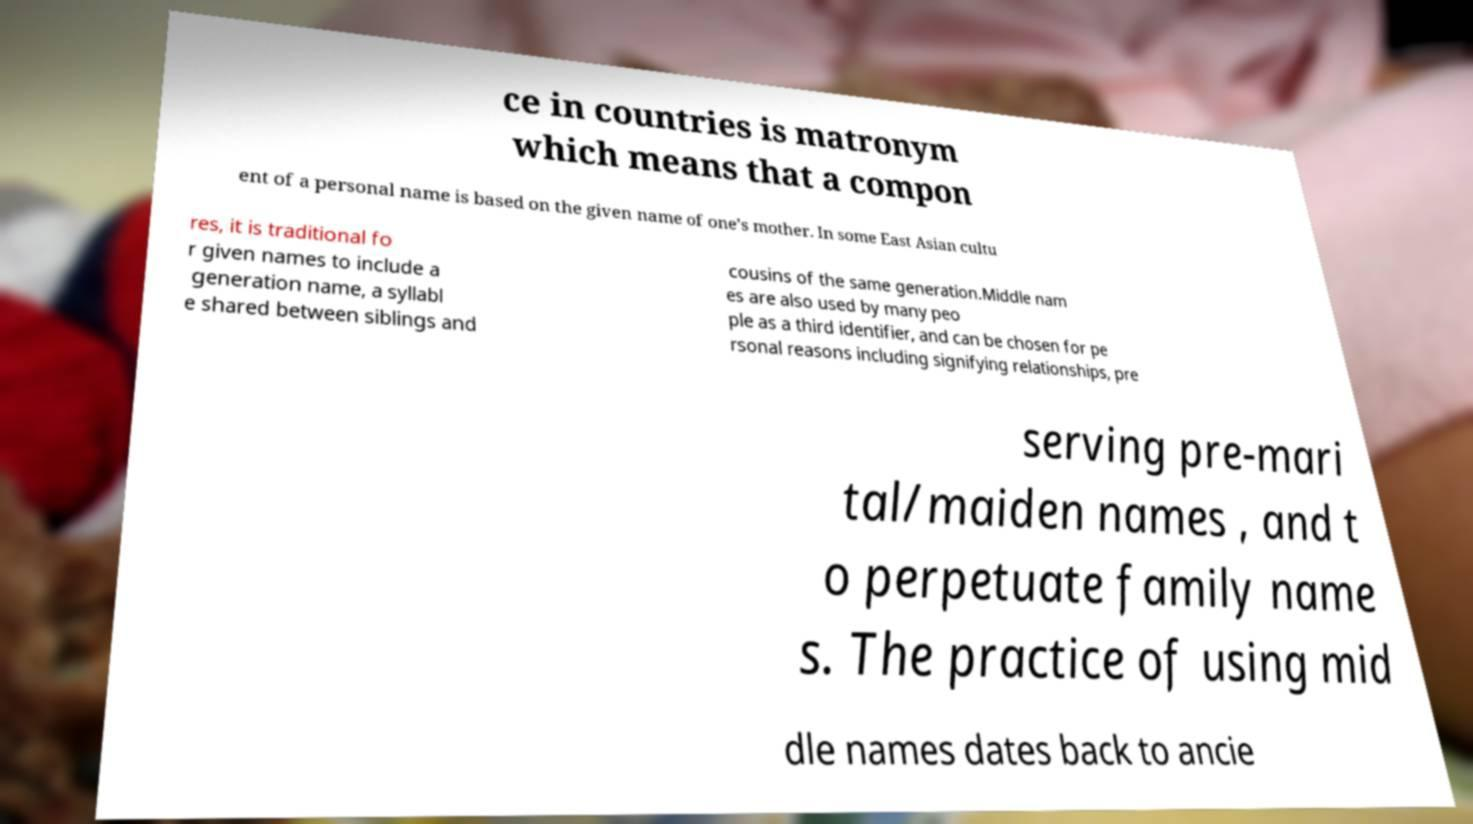Can you read and provide the text displayed in the image?This photo seems to have some interesting text. Can you extract and type it out for me? ce in countries is matronym which means that a compon ent of a personal name is based on the given name of one’s mother. In some East Asian cultu res, it is traditional fo r given names to include a generation name, a syllabl e shared between siblings and cousins of the same generation.Middle nam es are also used by many peo ple as a third identifier, and can be chosen for pe rsonal reasons including signifying relationships, pre serving pre-mari tal/maiden names , and t o perpetuate family name s. The practice of using mid dle names dates back to ancie 